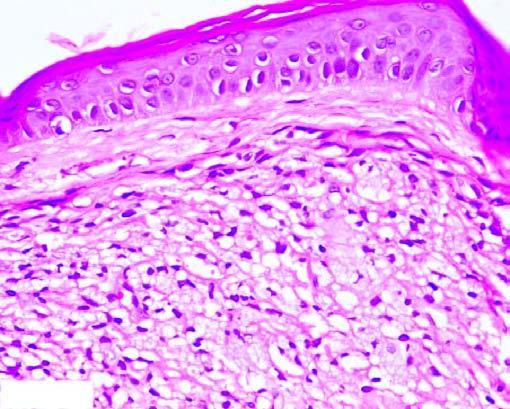s there collection of proliferating foam macrophages in the dermis with a clear subepidermal zone?
Answer the question using a single word or phrase. Yes 